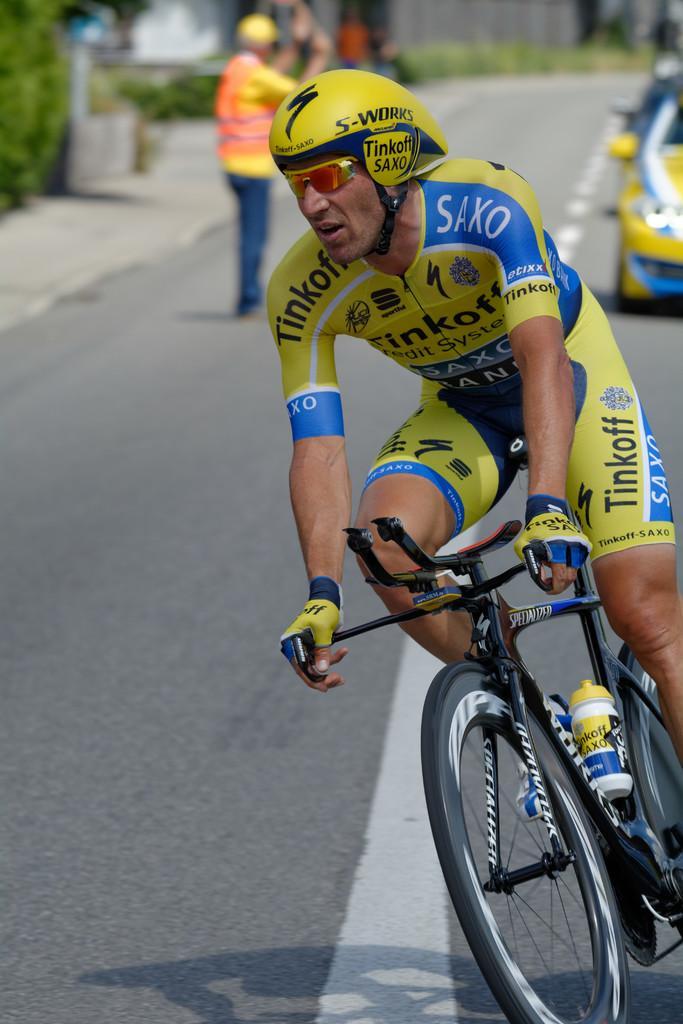In one or two sentences, can you explain what this image depicts? In this image we can see a man wearing the helmet and also glasses and cycling. In the background we can see a person and also the car on the road. We can also see the plants and people and the background is blurred. 